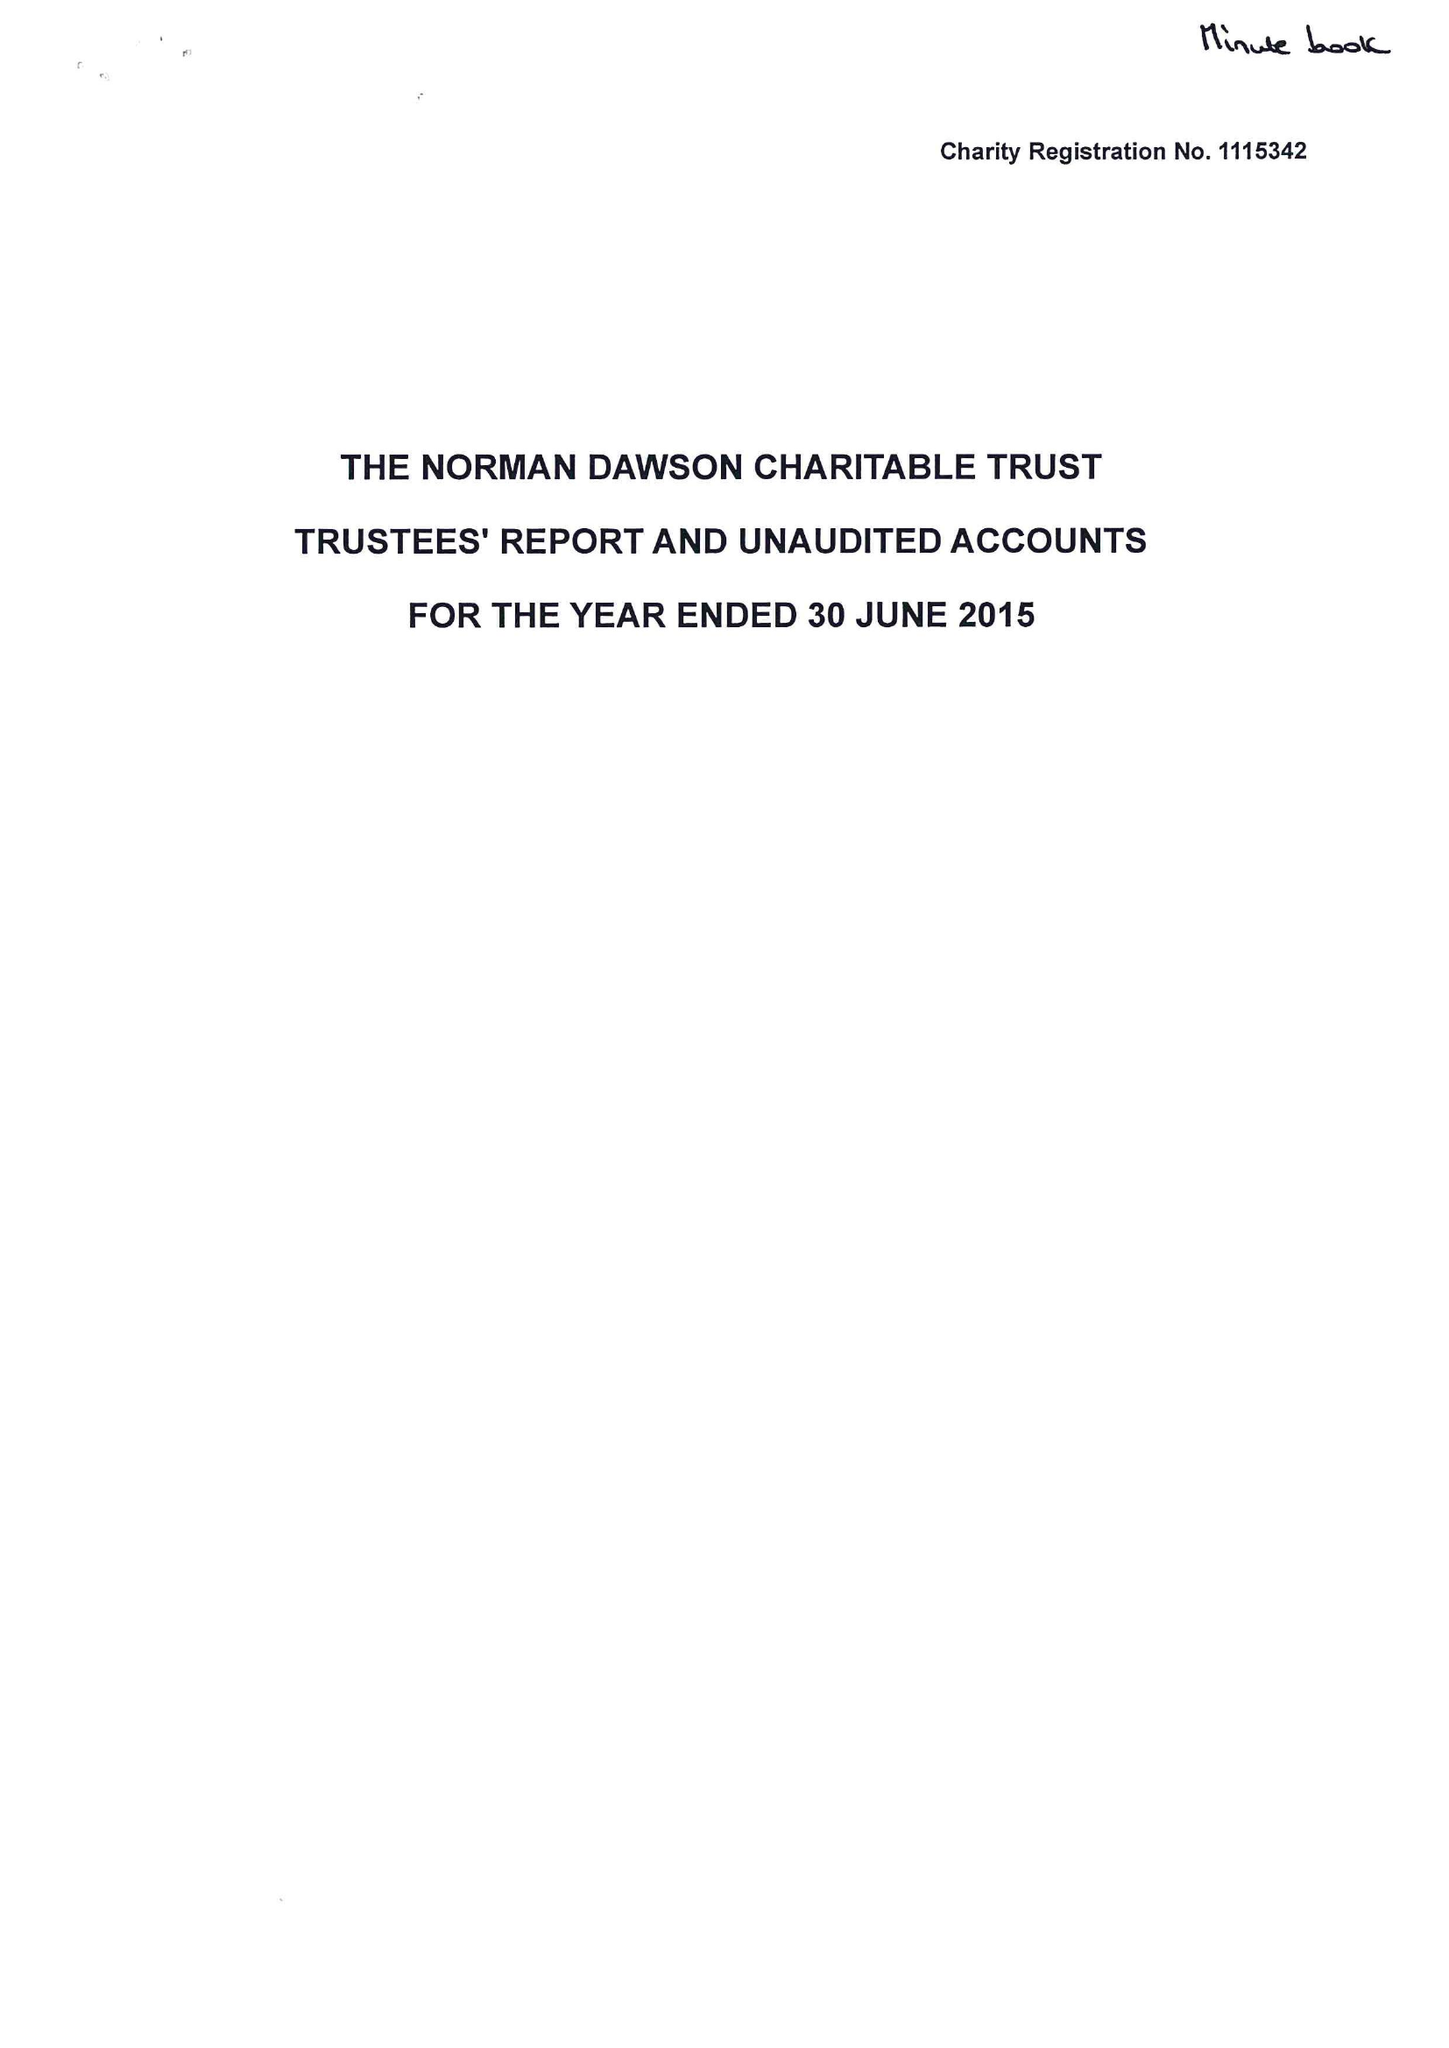What is the value for the income_annually_in_british_pounds?
Answer the question using a single word or phrase. 43094.00 